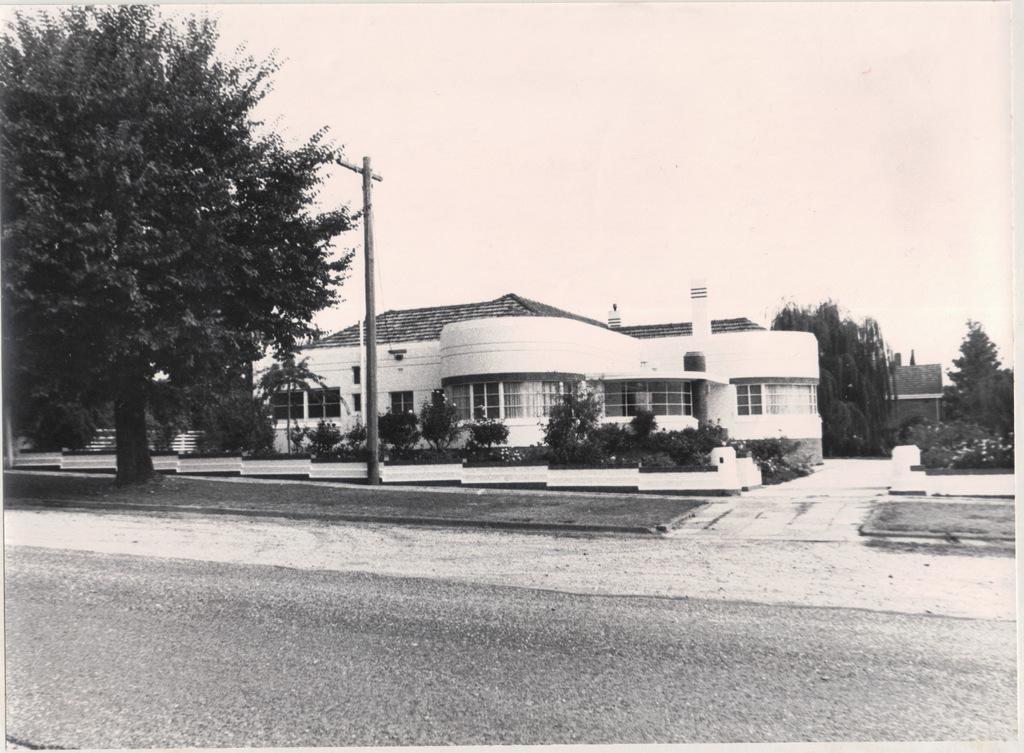What is the main feature of the image? There is a road in the image. What can be seen in the distance behind the road? There are buildings, trees, an electric pole, and the sky visible in the background of the image. What type of arithmetic problem is being solved on the side of the road in the image? There is no arithmetic problem visible in the image; it only features a road, buildings, trees, an electric pole, and the sky. Can you tell me how many volcanoes are present in the image? There are no volcanoes present in the image; it only features a road, buildings, trees, an electric pole, and the sky. 